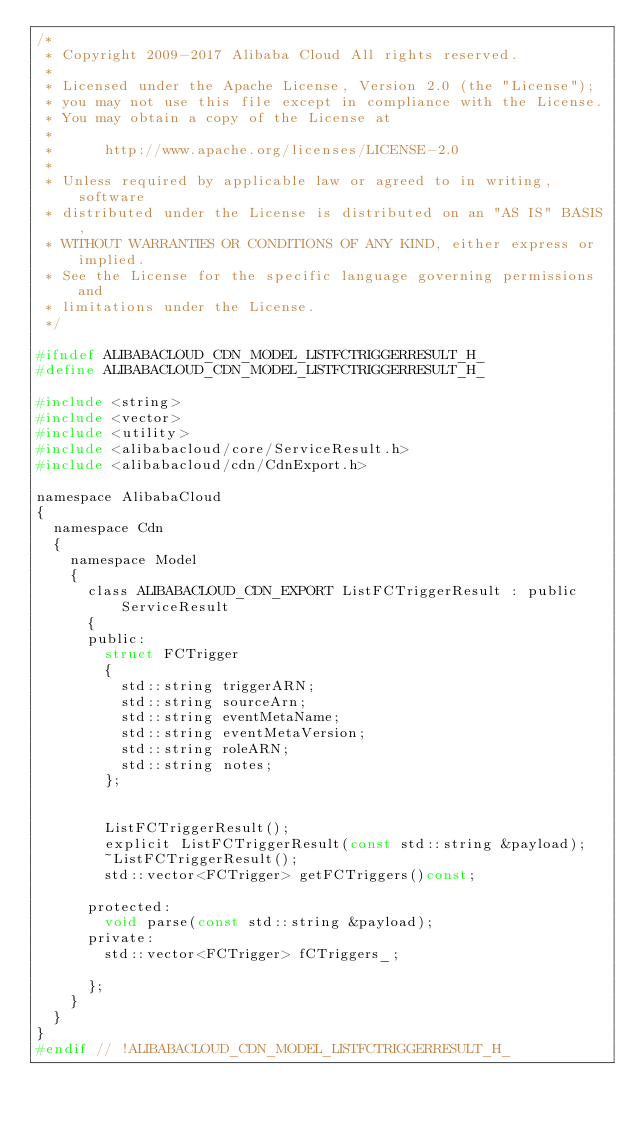<code> <loc_0><loc_0><loc_500><loc_500><_C_>/*
 * Copyright 2009-2017 Alibaba Cloud All rights reserved.
 * 
 * Licensed under the Apache License, Version 2.0 (the "License");
 * you may not use this file except in compliance with the License.
 * You may obtain a copy of the License at
 * 
 *      http://www.apache.org/licenses/LICENSE-2.0
 * 
 * Unless required by applicable law or agreed to in writing, software
 * distributed under the License is distributed on an "AS IS" BASIS,
 * WITHOUT WARRANTIES OR CONDITIONS OF ANY KIND, either express or implied.
 * See the License for the specific language governing permissions and
 * limitations under the License.
 */

#ifndef ALIBABACLOUD_CDN_MODEL_LISTFCTRIGGERRESULT_H_
#define ALIBABACLOUD_CDN_MODEL_LISTFCTRIGGERRESULT_H_

#include <string>
#include <vector>
#include <utility>
#include <alibabacloud/core/ServiceResult.h>
#include <alibabacloud/cdn/CdnExport.h>

namespace AlibabaCloud
{
	namespace Cdn
	{
		namespace Model
		{
			class ALIBABACLOUD_CDN_EXPORT ListFCTriggerResult : public ServiceResult
			{
			public:
				struct FCTrigger
				{
					std::string triggerARN;
					std::string sourceArn;
					std::string eventMetaName;
					std::string eventMetaVersion;
					std::string roleARN;
					std::string notes;
				};


				ListFCTriggerResult();
				explicit ListFCTriggerResult(const std::string &payload);
				~ListFCTriggerResult();
				std::vector<FCTrigger> getFCTriggers()const;

			protected:
				void parse(const std::string &payload);
			private:
				std::vector<FCTrigger> fCTriggers_;

			};
		}
	}
}
#endif // !ALIBABACLOUD_CDN_MODEL_LISTFCTRIGGERRESULT_H_</code> 